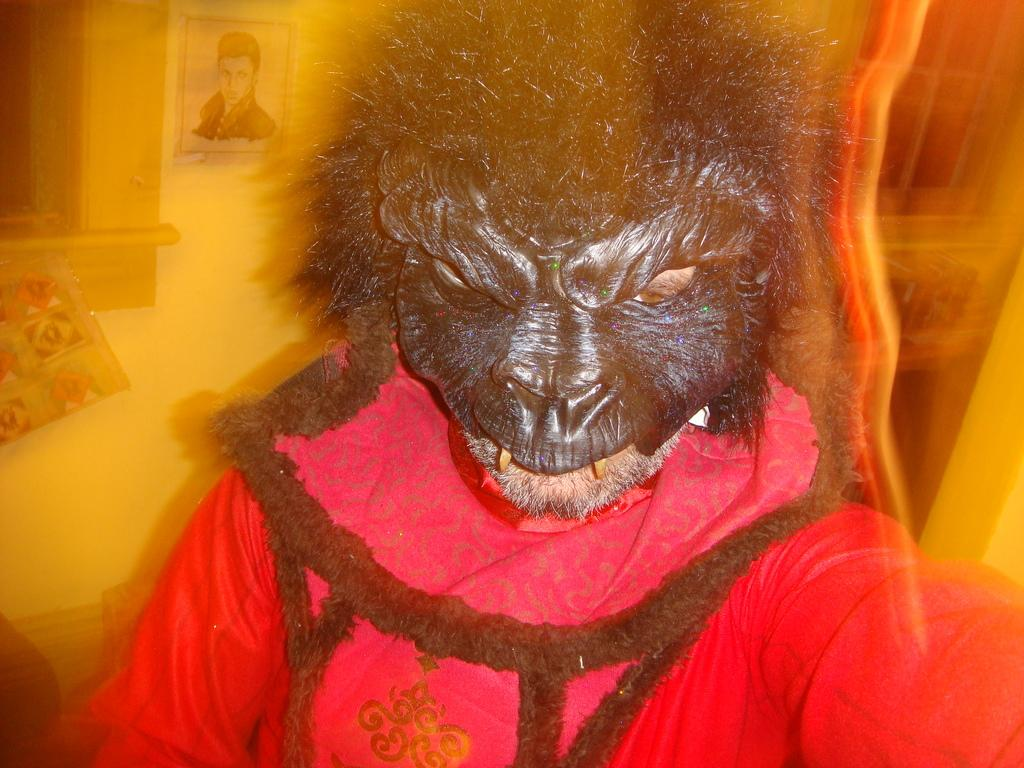Who or what is present in the image? There is a person in the image. What is the person wearing on their face? The person is wearing a mask. What else is the person wearing? The person is wearing a costume. Can you describe the background of the image? The background of the image is blurry. What type of land can be seen in the image? There is no land visible in the image; it features a person wearing a mask and costume against a blurry background. 